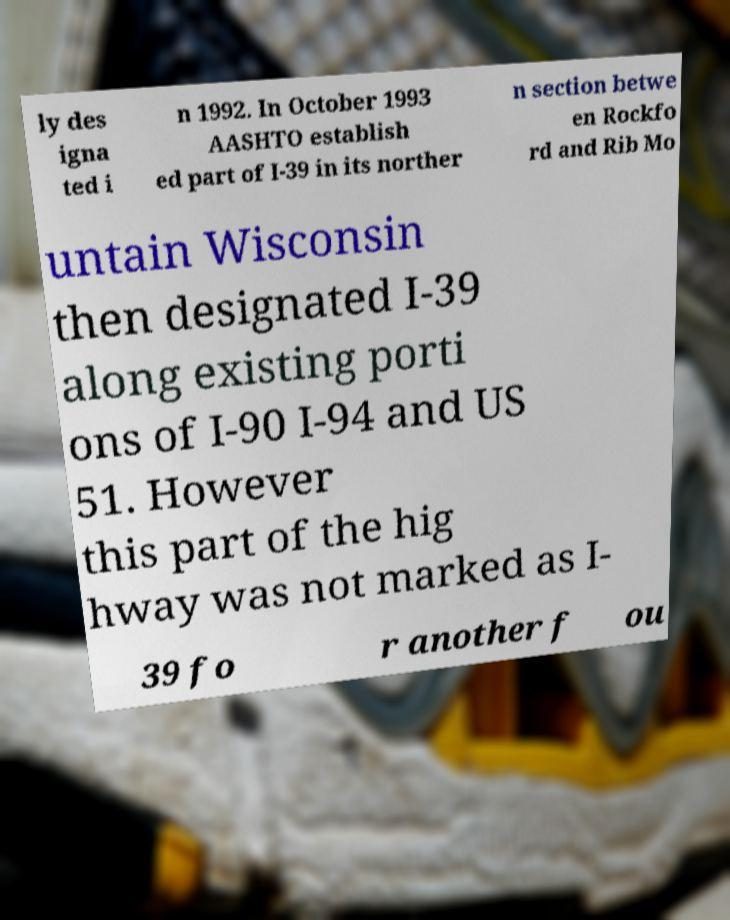Could you extract and type out the text from this image? ly des igna ted i n 1992. In October 1993 AASHTO establish ed part of I-39 in its norther n section betwe en Rockfo rd and Rib Mo untain Wisconsin then designated I-39 along existing porti ons of I-90 I-94 and US 51. However this part of the hig hway was not marked as I- 39 fo r another f ou 